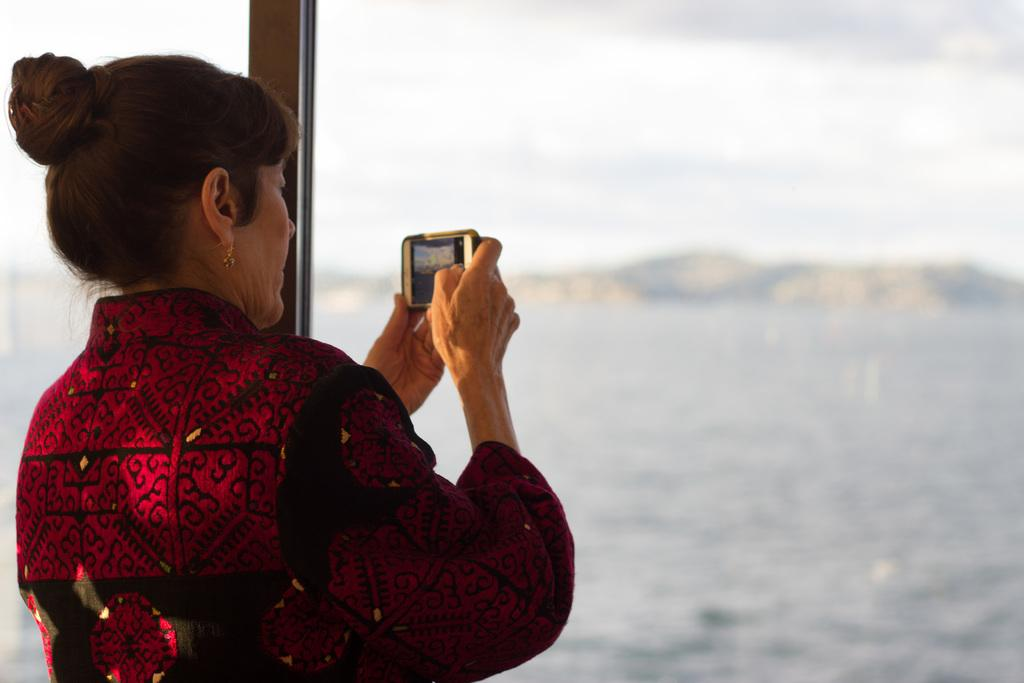Who is present in the image? There is a woman in the image. What is the woman holding in her hand? The woman is holding a mobile in her hand. What can be seen in the background of the image? There is water visible in the image. What type of bushes can be seen in the scene? There is no scene or bushes present in the image; it only features a woman holding a mobile and water in the background. 